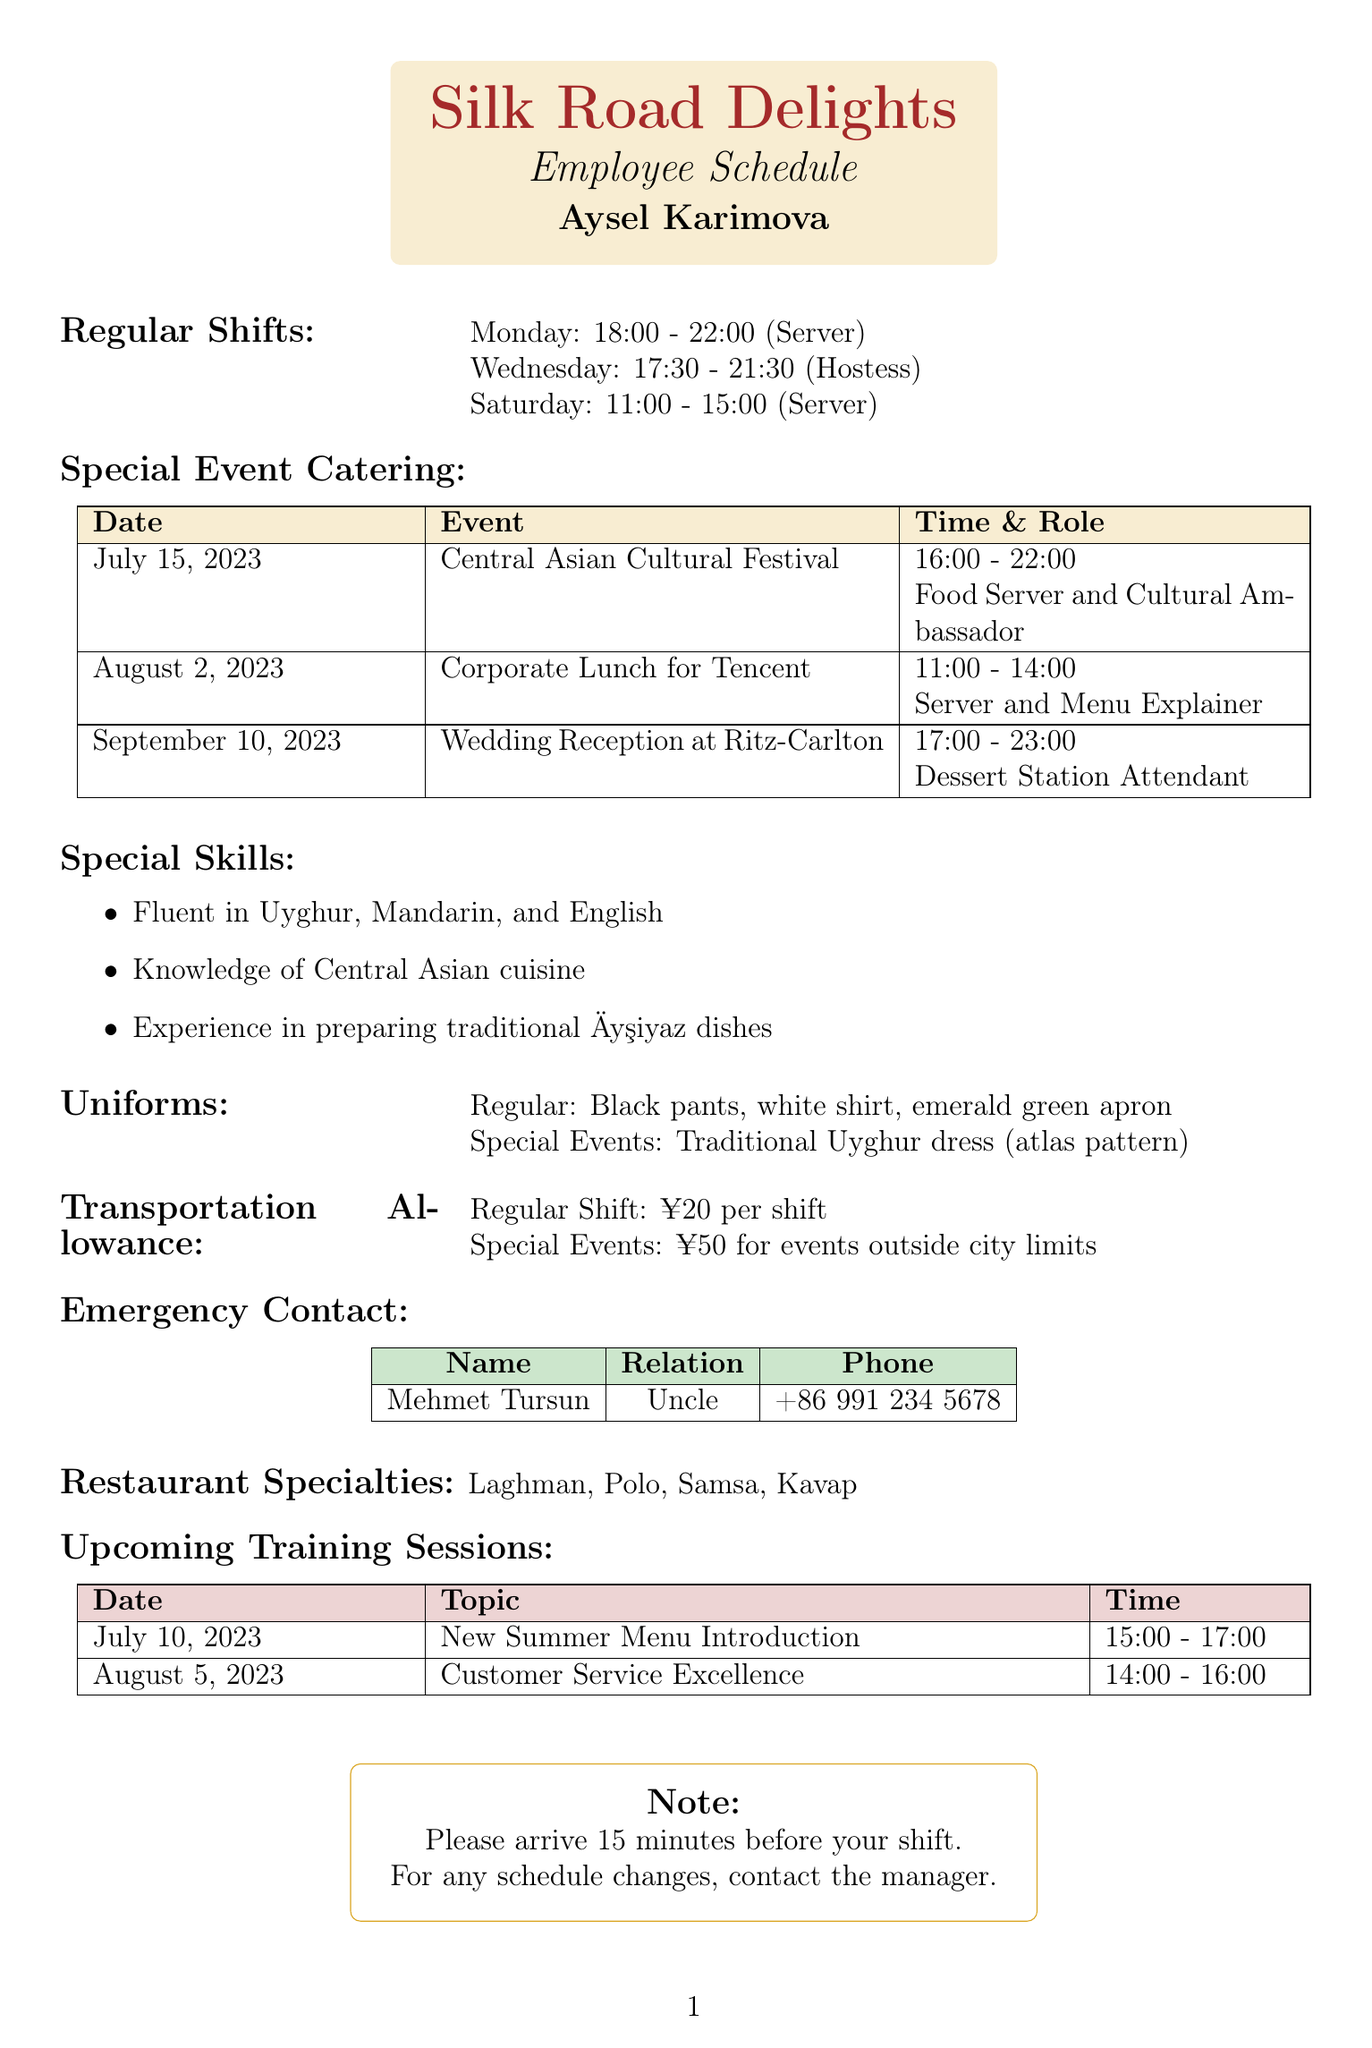What is the name of the restaurant? The restaurant name is specified at the top of the document.
Answer: Silk Road Delights What role does Aysel have on Monday? The regular shift schedule lists Aysel's role for Monday.
Answer: Server When is the Corporate Lunch for Tencent? The special event catering section includes the date of the Corporate Lunch.
Answer: August 2, 2023 What time does the Wedding Reception at Ritz-Carlton start? The document states the time for the Wedding Reception in the special event catering section.
Answer: 17:00 What is the emergency contact's relation to Aysel? The emergency contact details specify the relation to Aysel.
Answer: Uncle How much is the transportation allowance for special events? The transportation allowance section states the amount for special events outside city limits.
Answer: ¥50 Which languages can Aysel speak? The special skills section lists the languages Aysel is fluent in.
Answer: Uyghur, Mandarin, and English What is the last scheduled training session? The upcoming training sessions list the topics and dates, with the last one being the most recent.
Answer: Customer Service Excellence What type of uniform is required for special events? The uniforms section specifies the clothing required for special events.
Answer: Traditional Uyghur dress (atlas pattern) 